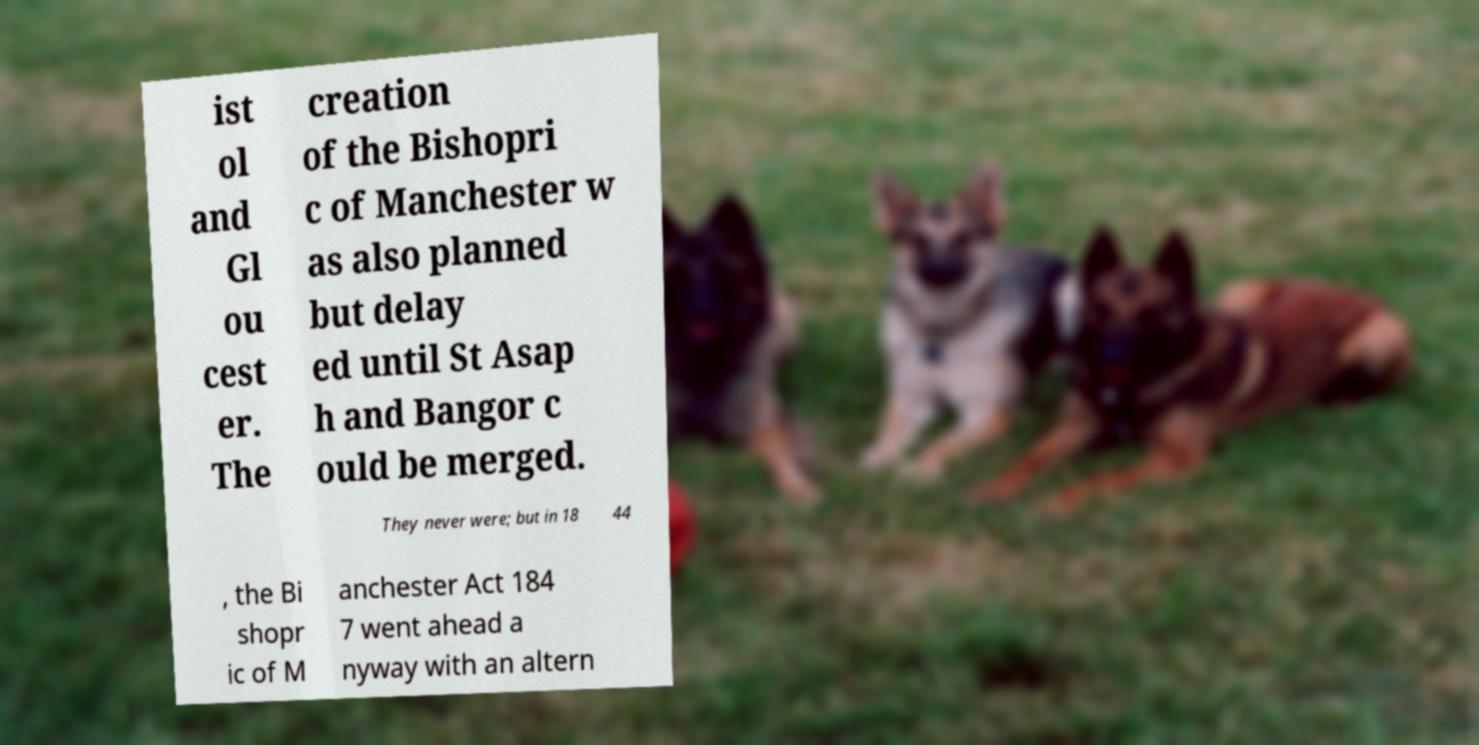Please identify and transcribe the text found in this image. ist ol and Gl ou cest er. The creation of the Bishopri c of Manchester w as also planned but delay ed until St Asap h and Bangor c ould be merged. They never were; but in 18 44 , the Bi shopr ic of M anchester Act 184 7 went ahead a nyway with an altern 